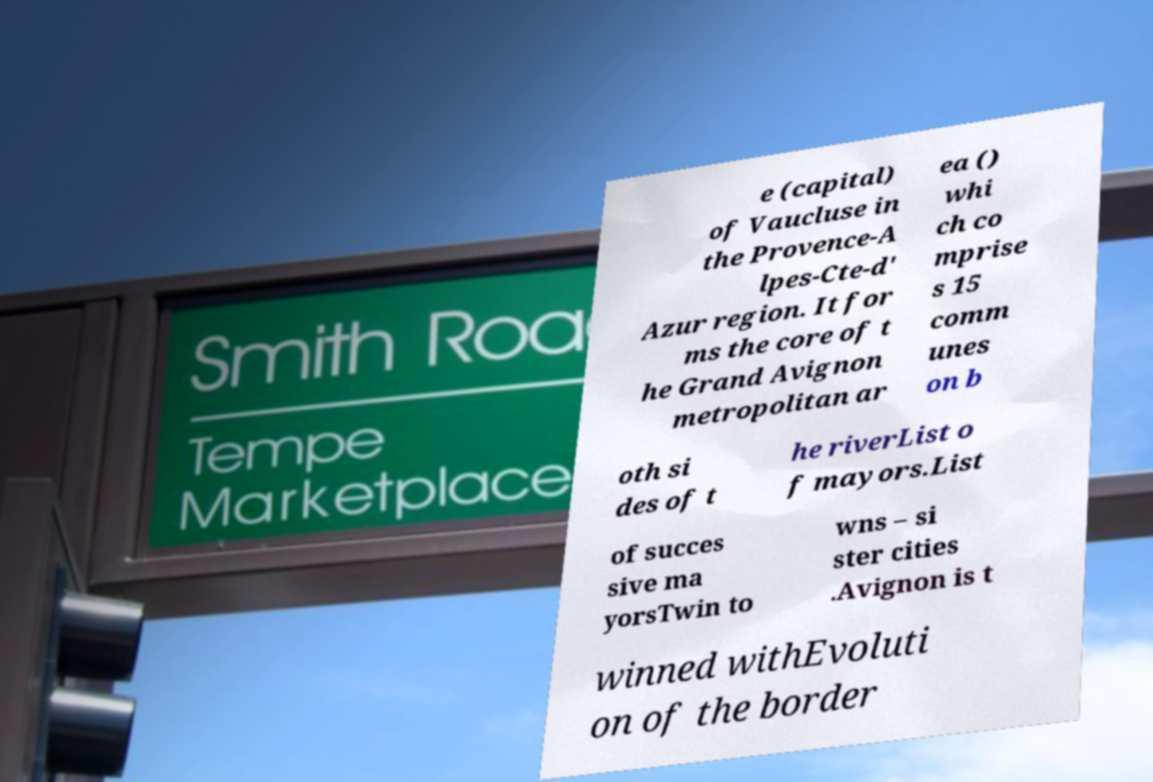Could you extract and type out the text from this image? e (capital) of Vaucluse in the Provence-A lpes-Cte-d' Azur region. It for ms the core of t he Grand Avignon metropolitan ar ea () whi ch co mprise s 15 comm unes on b oth si des of t he riverList o f mayors.List of succes sive ma yorsTwin to wns – si ster cities .Avignon is t winned withEvoluti on of the border 